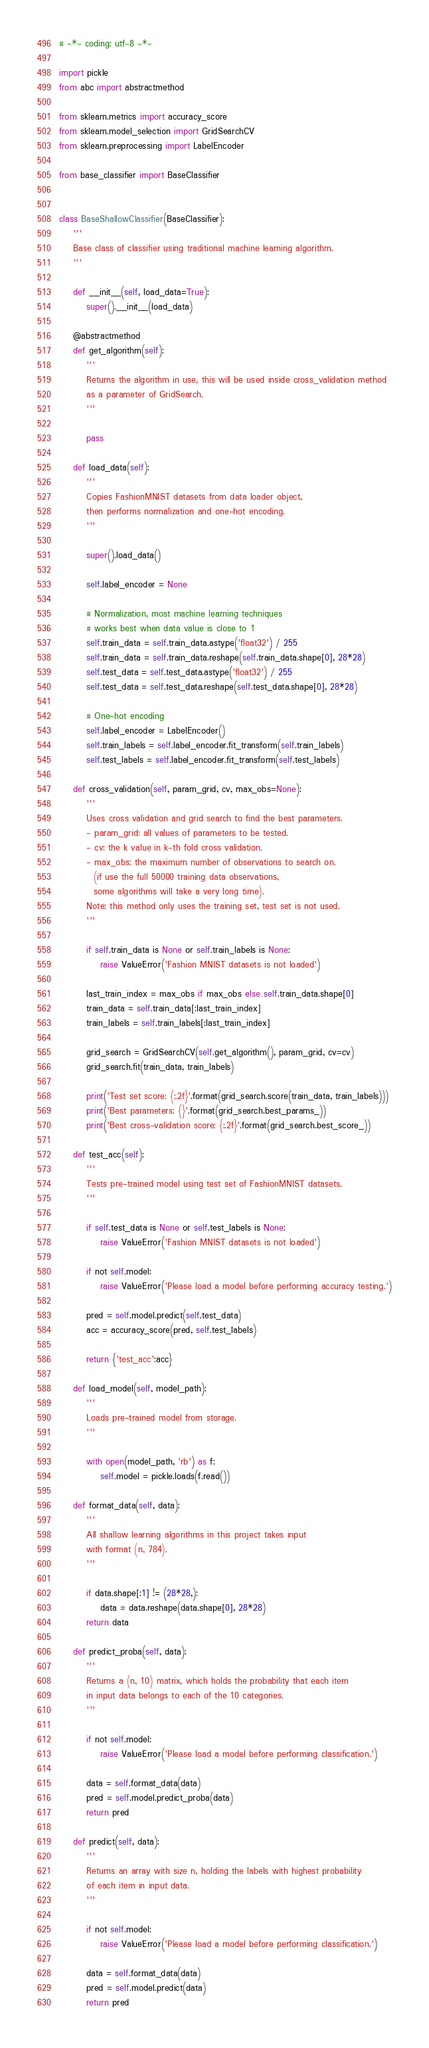<code> <loc_0><loc_0><loc_500><loc_500><_Python_># -*- coding: utf-8 -*-

import pickle
from abc import abstractmethod

from sklearn.metrics import accuracy_score
from sklearn.model_selection import GridSearchCV
from sklearn.preprocessing import LabelEncoder

from base_classifier import BaseClassifier


class BaseShallowClassifier(BaseClassifier):
    '''
    Base class of classifier using traditional machine learning algorithm.
    '''

    def __init__(self, load_data=True):
        super().__init__(load_data)

    @abstractmethod
    def get_algorithm(self):
        '''
        Returns the algorithm in use, this will be used inside cross_validation method
        as a parameter of GridSearch.
        '''

        pass

    def load_data(self):
        '''
        Copies FashionMNIST datasets from data loader object,
        then performs normalization and one-hot encoding.
        '''

        super().load_data()

        self.label_encoder = None

        # Normalization, most machine learning techniques 
        # works best when data value is close to 1
        self.train_data = self.train_data.astype('float32') / 255
        self.train_data = self.train_data.reshape(self.train_data.shape[0], 28*28)
        self.test_data = self.test_data.astype('float32') / 255
        self.test_data = self.test_data.reshape(self.test_data.shape[0], 28*28)
        
        # One-hot encoding
        self.label_encoder = LabelEncoder()
        self.train_labels = self.label_encoder.fit_transform(self.train_labels)
        self.test_labels = self.label_encoder.fit_transform(self.test_labels)

    def cross_validation(self, param_grid, cv, max_obs=None):
        '''
        Uses cross validation and grid search to find the best parameters.
        - param_grid: all values of parameters to be tested.
        - cv: the k value in k-th fold cross validation.
        - max_obs: the maximum number of observations to search on.
          (if use the full 50000 training data observations,
          some algorithms will take a very long time).
        Note: this method only uses the training set, test set is not used.
        '''

        if self.train_data is None or self.train_labels is None:
            raise ValueError('Fashion MNIST datasets is not loaded') 

        last_train_index = max_obs if max_obs else self.train_data.shape[0]
        train_data = self.train_data[:last_train_index]
        train_labels = self.train_labels[:last_train_index]

        grid_search = GridSearchCV(self.get_algorithm(), param_grid, cv=cv)
        grid_search.fit(train_data, train_labels)

        print('Test set score: {:.2f}'.format(grid_search.score(train_data, train_labels)))
        print('Best parameters: {}'.format(grid_search.best_params_))
        print('Best cross-validation score: {:.2f}'.format(grid_search.best_score_))

    def test_acc(self):
        '''
        Tests pre-trained model using test set of FashionMNIST datasets.
        '''

        if self.test_data is None or self.test_labels is None:
            raise ValueError('Fashion MNIST datasets is not loaded') 
    
        if not self.model:
            raise ValueError('Please load a model before performing accuracy testing.')

        pred = self.model.predict(self.test_data)
        acc = accuracy_score(pred, self.test_labels)

        return {'test_acc':acc}

    def load_model(self, model_path):
        '''
        Loads pre-trained model from storage.
        '''

        with open(model_path, 'rb') as f:
            self.model = pickle.loads(f.read())

    def format_data(self, data):
        '''
        All shallow learning algorithms in this project takes input
        with format (n, 784).
        '''

        if data.shape[:1] != (28*28,):
            data = data.reshape(data.shape[0], 28*28)
        return data

    def predict_proba(self, data):
        '''
        Returns a (n, 10) matrix, which holds the probability that each item
        in input data belongs to each of the 10 categories.
        '''

        if not self.model:
            raise ValueError('Please load a model before performing classification.')

        data = self.format_data(data)
        pred = self.model.predict_proba(data)
        return pred
    
    def predict(self, data):
        '''
        Returns an array with size n, holding the labels with highest probability
        of each item in input data.
        '''

        if not self.model:
            raise ValueError('Please load a model before performing classification.')

        data = self.format_data(data)
        pred = self.model.predict(data)
        return pred
</code> 